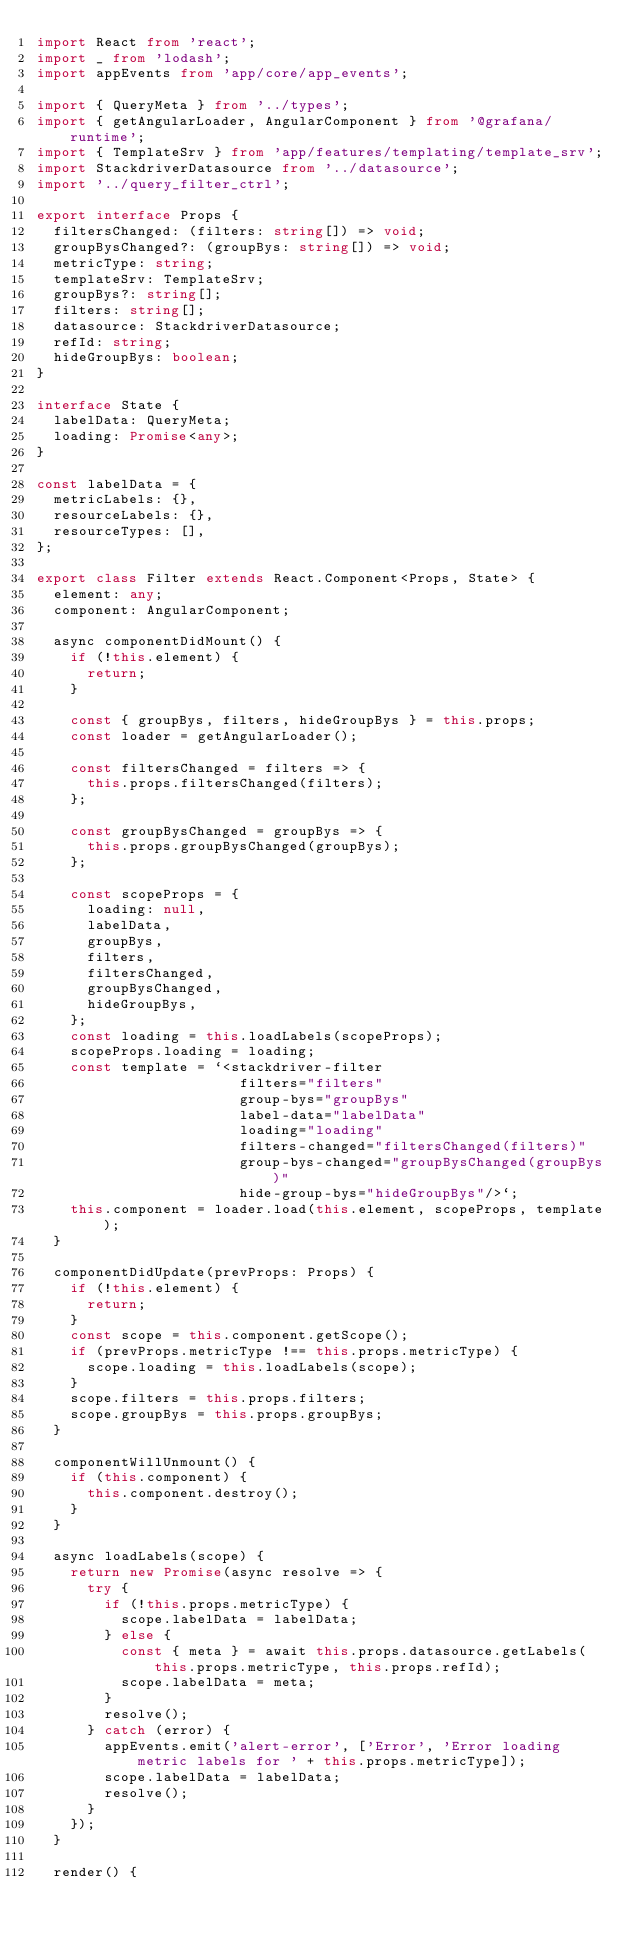<code> <loc_0><loc_0><loc_500><loc_500><_TypeScript_>import React from 'react';
import _ from 'lodash';
import appEvents from 'app/core/app_events';

import { QueryMeta } from '../types';
import { getAngularLoader, AngularComponent } from '@grafana/runtime';
import { TemplateSrv } from 'app/features/templating/template_srv';
import StackdriverDatasource from '../datasource';
import '../query_filter_ctrl';

export interface Props {
  filtersChanged: (filters: string[]) => void;
  groupBysChanged?: (groupBys: string[]) => void;
  metricType: string;
  templateSrv: TemplateSrv;
  groupBys?: string[];
  filters: string[];
  datasource: StackdriverDatasource;
  refId: string;
  hideGroupBys: boolean;
}

interface State {
  labelData: QueryMeta;
  loading: Promise<any>;
}

const labelData = {
  metricLabels: {},
  resourceLabels: {},
  resourceTypes: [],
};

export class Filter extends React.Component<Props, State> {
  element: any;
  component: AngularComponent;

  async componentDidMount() {
    if (!this.element) {
      return;
    }

    const { groupBys, filters, hideGroupBys } = this.props;
    const loader = getAngularLoader();

    const filtersChanged = filters => {
      this.props.filtersChanged(filters);
    };

    const groupBysChanged = groupBys => {
      this.props.groupBysChanged(groupBys);
    };

    const scopeProps = {
      loading: null,
      labelData,
      groupBys,
      filters,
      filtersChanged,
      groupBysChanged,
      hideGroupBys,
    };
    const loading = this.loadLabels(scopeProps);
    scopeProps.loading = loading;
    const template = `<stackdriver-filter
                        filters="filters"
                        group-bys="groupBys"
                        label-data="labelData"
                        loading="loading"
                        filters-changed="filtersChanged(filters)"
                        group-bys-changed="groupBysChanged(groupBys)"
                        hide-group-bys="hideGroupBys"/>`;
    this.component = loader.load(this.element, scopeProps, template);
  }

  componentDidUpdate(prevProps: Props) {
    if (!this.element) {
      return;
    }
    const scope = this.component.getScope();
    if (prevProps.metricType !== this.props.metricType) {
      scope.loading = this.loadLabels(scope);
    }
    scope.filters = this.props.filters;
    scope.groupBys = this.props.groupBys;
  }

  componentWillUnmount() {
    if (this.component) {
      this.component.destroy();
    }
  }

  async loadLabels(scope) {
    return new Promise(async resolve => {
      try {
        if (!this.props.metricType) {
          scope.labelData = labelData;
        } else {
          const { meta } = await this.props.datasource.getLabels(this.props.metricType, this.props.refId);
          scope.labelData = meta;
        }
        resolve();
      } catch (error) {
        appEvents.emit('alert-error', ['Error', 'Error loading metric labels for ' + this.props.metricType]);
        scope.labelData = labelData;
        resolve();
      }
    });
  }

  render() {</code> 